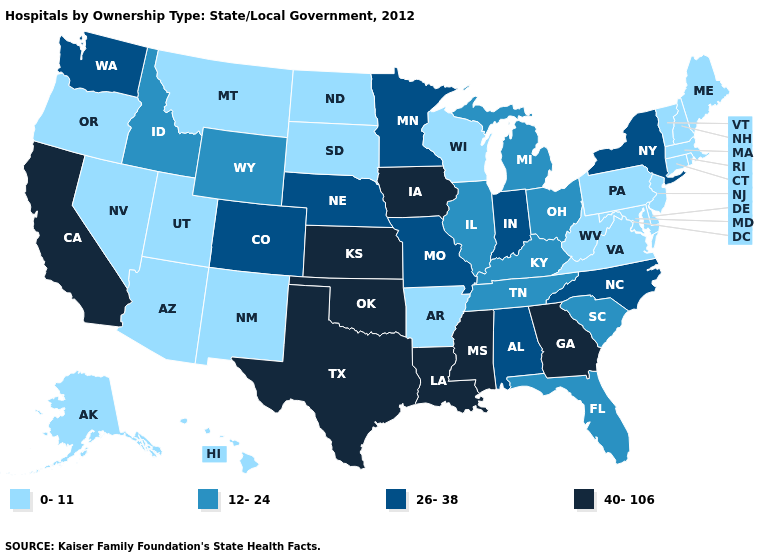Does Georgia have the lowest value in the South?
Quick response, please. No. Which states have the lowest value in the USA?
Answer briefly. Alaska, Arizona, Arkansas, Connecticut, Delaware, Hawaii, Maine, Maryland, Massachusetts, Montana, Nevada, New Hampshire, New Jersey, New Mexico, North Dakota, Oregon, Pennsylvania, Rhode Island, South Dakota, Utah, Vermont, Virginia, West Virginia, Wisconsin. Which states have the highest value in the USA?
Quick response, please. California, Georgia, Iowa, Kansas, Louisiana, Mississippi, Oklahoma, Texas. Among the states that border Montana , which have the lowest value?
Write a very short answer. North Dakota, South Dakota. What is the highest value in states that border North Dakota?
Concise answer only. 26-38. Does Arkansas have the lowest value in the USA?
Quick response, please. Yes. Does Wyoming have the lowest value in the West?
Give a very brief answer. No. Does Utah have a higher value than Maryland?
Give a very brief answer. No. Which states have the lowest value in the USA?
Keep it brief. Alaska, Arizona, Arkansas, Connecticut, Delaware, Hawaii, Maine, Maryland, Massachusetts, Montana, Nevada, New Hampshire, New Jersey, New Mexico, North Dakota, Oregon, Pennsylvania, Rhode Island, South Dakota, Utah, Vermont, Virginia, West Virginia, Wisconsin. What is the value of Washington?
Concise answer only. 26-38. Name the states that have a value in the range 26-38?
Keep it brief. Alabama, Colorado, Indiana, Minnesota, Missouri, Nebraska, New York, North Carolina, Washington. What is the value of Virginia?
Concise answer only. 0-11. What is the highest value in the West ?
Give a very brief answer. 40-106. Is the legend a continuous bar?
Quick response, please. No. Does Maine have the lowest value in the USA?
Answer briefly. Yes. 